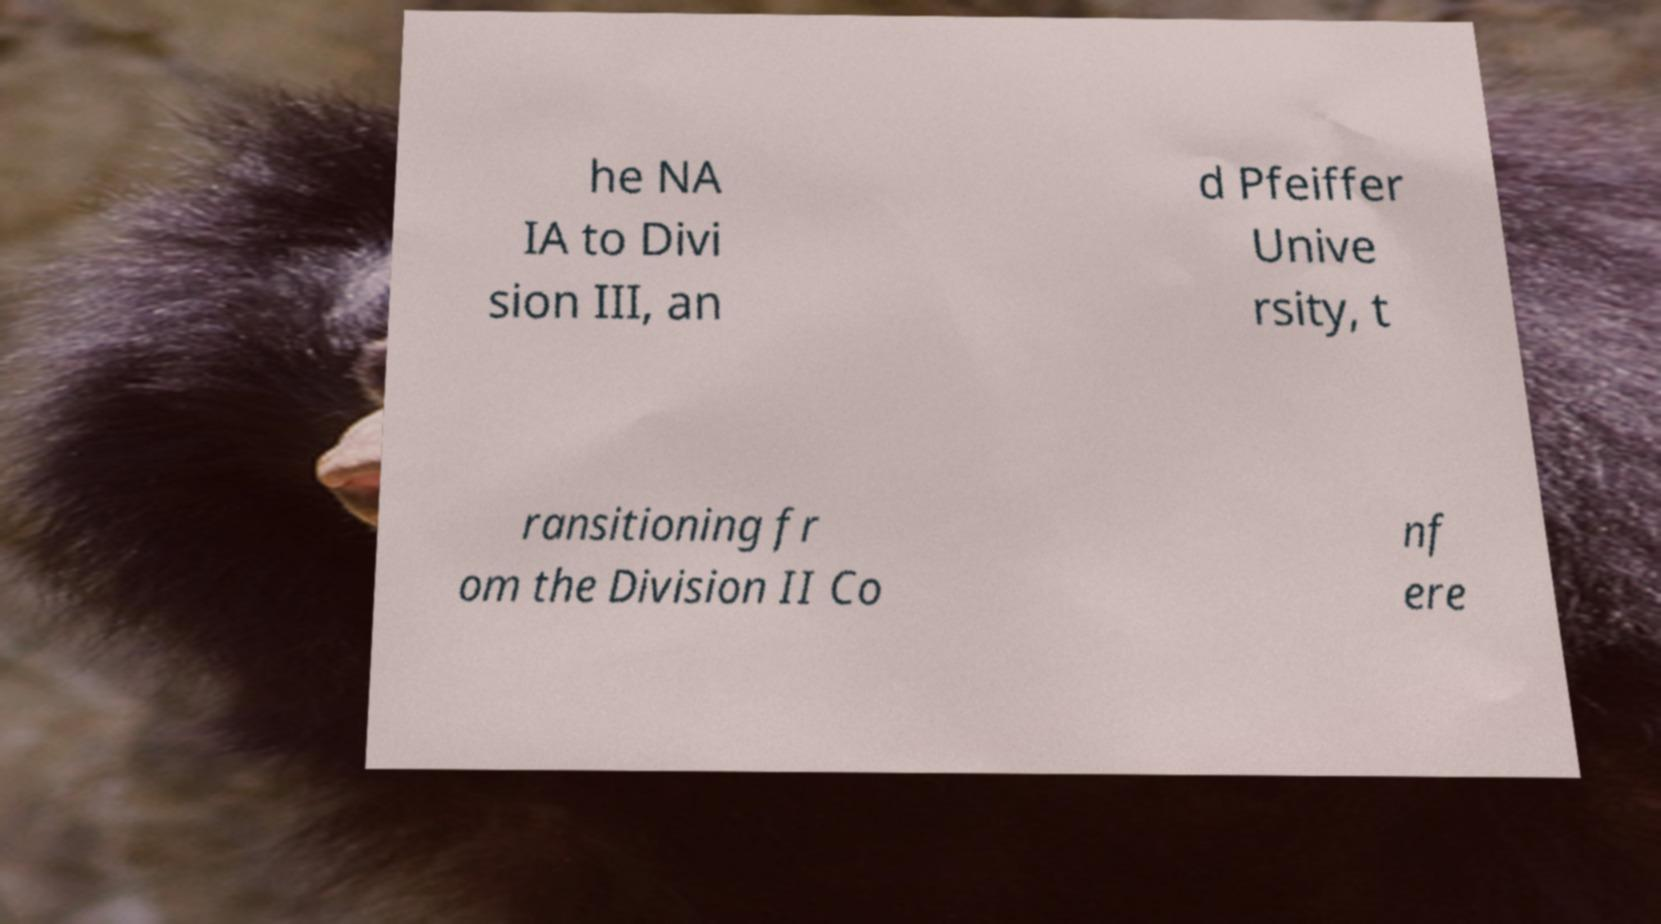Could you extract and type out the text from this image? he NA IA to Divi sion III, an d Pfeiffer Unive rsity, t ransitioning fr om the Division II Co nf ere 